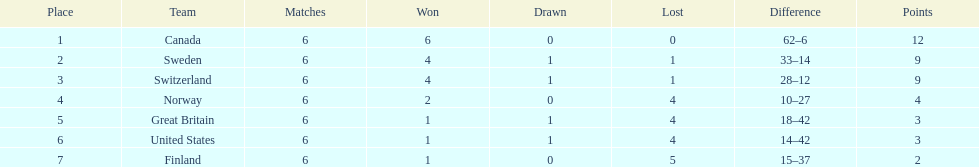What are the names of the countries? Canada, Sweden, Switzerland, Norway, Great Britain, United States, Finland. How many wins did switzerland have? 4. How many wins did great britain have? 1. Which country had more wins, great britain or switzerland? Switzerland. 